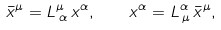Convert formula to latex. <formula><loc_0><loc_0><loc_500><loc_500>\bar { x } ^ { \mu } = L ^ { \mu } _ { \, \alpha } \, x ^ { \alpha } , \quad x ^ { \alpha } = L ^ { \alpha } _ { \, \mu } \, \bar { x } ^ { \mu } ,</formula> 